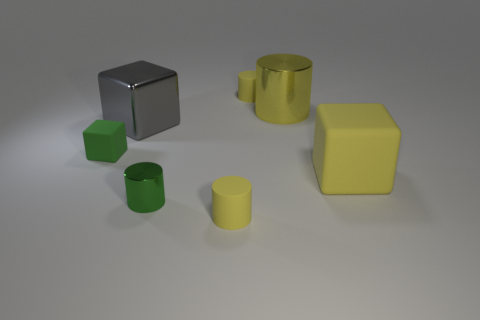What is the shape of the large thing that is the same color as the large cylinder?
Provide a succinct answer. Cube. Is the number of gray blocks on the right side of the large metallic block greater than the number of large green shiny objects?
Keep it short and to the point. No. Is there any other thing that has the same shape as the tiny green metallic object?
Offer a very short reply. Yes. The other small object that is the same shape as the gray object is what color?
Your response must be concise. Green. What shape is the tiny yellow thing that is in front of the yellow matte block?
Make the answer very short. Cylinder. There is a gray block; are there any tiny metallic things left of it?
Offer a very short reply. No. Are there any other things that are the same size as the green metallic object?
Your response must be concise. Yes. There is a large cylinder that is the same material as the gray thing; what color is it?
Ensure brevity in your answer.  Yellow. Do the metal cylinder behind the big rubber block and the small matte cylinder that is in front of the large yellow metallic thing have the same color?
Offer a terse response. Yes. How many blocks are either small metallic things or large gray matte objects?
Your answer should be very brief. 0. 